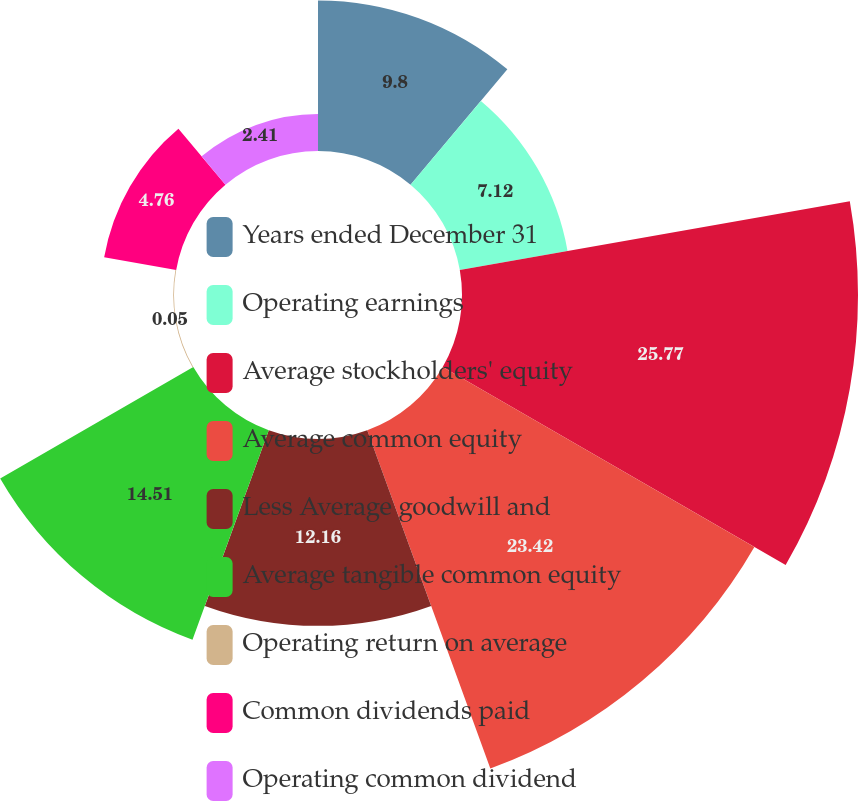Convert chart to OTSL. <chart><loc_0><loc_0><loc_500><loc_500><pie_chart><fcel>Years ended December 31<fcel>Operating earnings<fcel>Average stockholders' equity<fcel>Average common equity<fcel>Less Average goodwill and<fcel>Average tangible common equity<fcel>Operating return on average<fcel>Common dividends paid<fcel>Operating common dividend<nl><fcel>9.8%<fcel>7.12%<fcel>25.77%<fcel>23.42%<fcel>12.16%<fcel>14.51%<fcel>0.05%<fcel>4.76%<fcel>2.41%<nl></chart> 